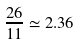Convert formula to latex. <formula><loc_0><loc_0><loc_500><loc_500>\frac { 2 6 } { 1 1 } \simeq 2 . 3 6</formula> 